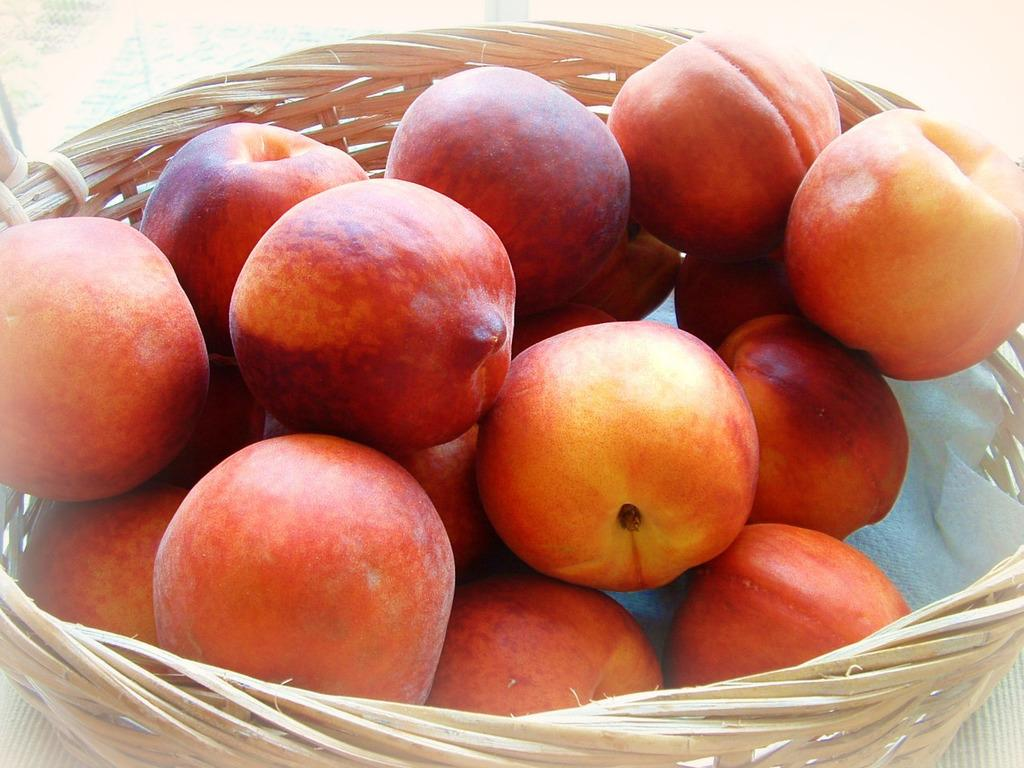What is in the basket that is visible in the image? There is a basket with fruits in the image. Where is the basket located in the image? The basket is on an object that resembles a table. What type of industry is depicted in the image? There is no industry depicted in the image; it features a basket of fruits on a table-like object. How does the flag blow in the image? There is no flag present in the image, so it cannot be determined how it might blow. 